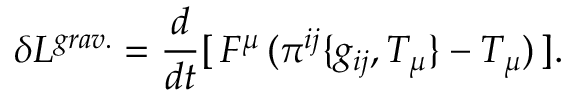Convert formula to latex. <formula><loc_0><loc_0><loc_500><loc_500>\delta L ^ { g r a v . } = \frac { d } { d t } [ \, F ^ { \mu } \, ( \pi ^ { i j } \{ g _ { i j } , T _ { \mu } \} - T _ { \mu } ) \, ] .</formula> 